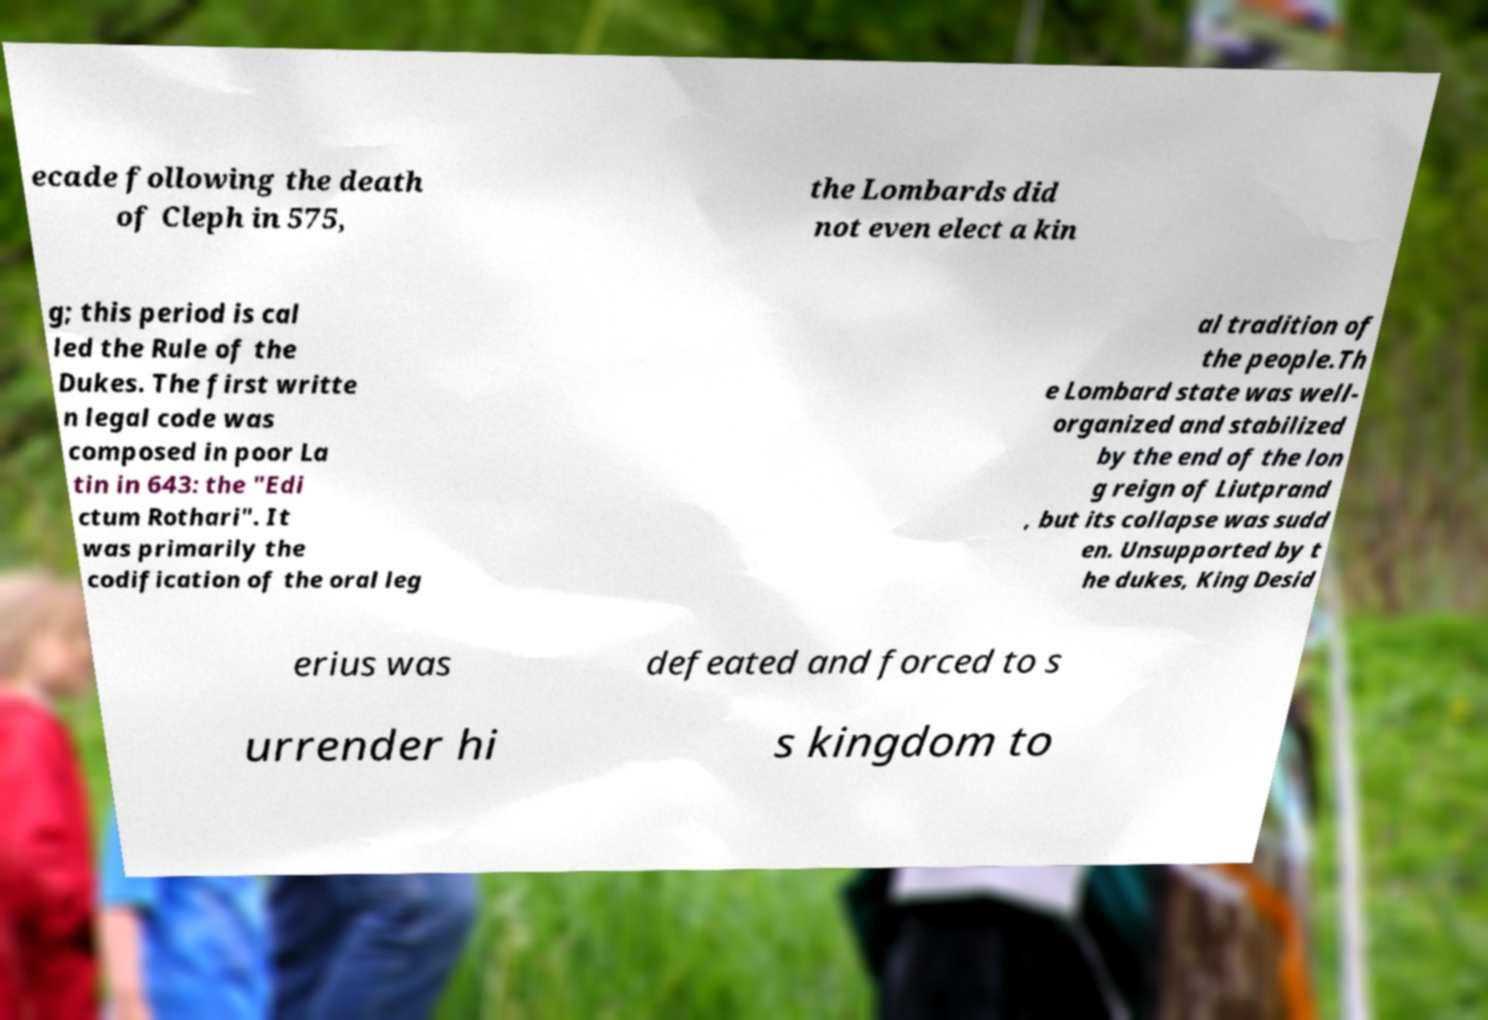There's text embedded in this image that I need extracted. Can you transcribe it verbatim? ecade following the death of Cleph in 575, the Lombards did not even elect a kin g; this period is cal led the Rule of the Dukes. The first writte n legal code was composed in poor La tin in 643: the "Edi ctum Rothari". It was primarily the codification of the oral leg al tradition of the people.Th e Lombard state was well- organized and stabilized by the end of the lon g reign of Liutprand , but its collapse was sudd en. Unsupported by t he dukes, King Desid erius was defeated and forced to s urrender hi s kingdom to 